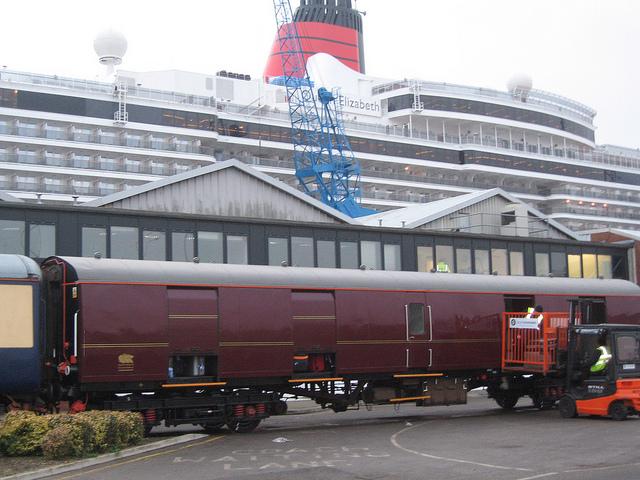What color is the forklift?
Be succinct. Blue. Which of these vehicles would float?
Short answer required. Boat. What color is the crane?
Keep it brief. Blue. 